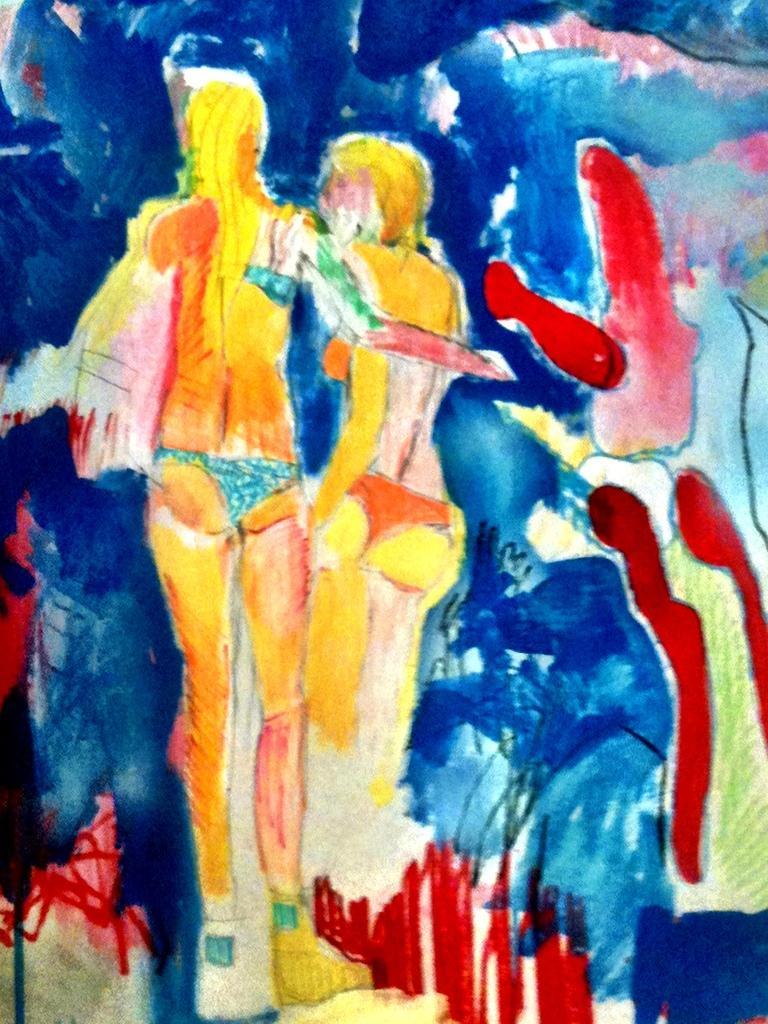Can you describe this image briefly? In the image there is a sketch painting of two women in bikini. 